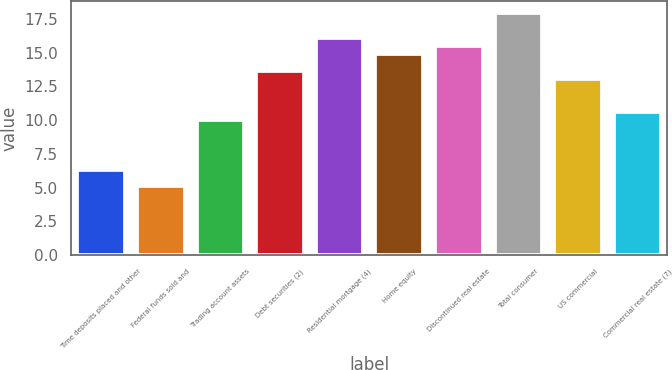<chart> <loc_0><loc_0><loc_500><loc_500><bar_chart><fcel>Time deposits placed and other<fcel>Federal funds sold and<fcel>Trading account assets<fcel>Debt securities (2)<fcel>Residential mortgage (4)<fcel>Home equity<fcel>Discontinued real estate<fcel>Total consumer<fcel>US commercial<fcel>Commercial real estate (7)<nl><fcel>6.32<fcel>5.1<fcel>9.98<fcel>13.64<fcel>16.08<fcel>14.86<fcel>15.47<fcel>17.91<fcel>13.03<fcel>10.59<nl></chart> 